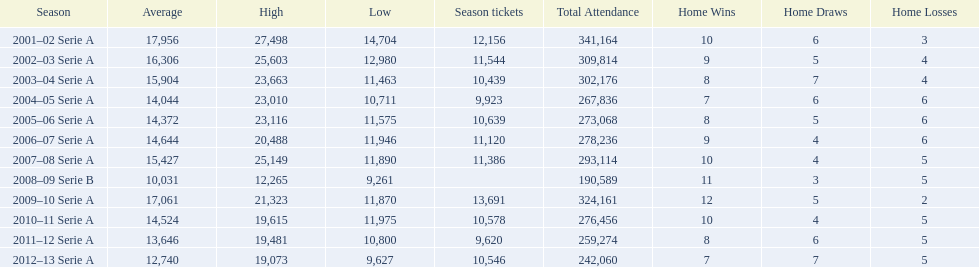When were all of the seasons? 2001–02 Serie A, 2002–03 Serie A, 2003–04 Serie A, 2004–05 Serie A, 2005–06 Serie A, 2006–07 Serie A, 2007–08 Serie A, 2008–09 Serie B, 2009–10 Serie A, 2010–11 Serie A, 2011–12 Serie A, 2012–13 Serie A. How many tickets were sold? 12,156, 11,544, 10,439, 9,923, 10,639, 11,120, 11,386, , 13,691, 10,578, 9,620, 10,546. What about just during the 2007 season? 11,386. 